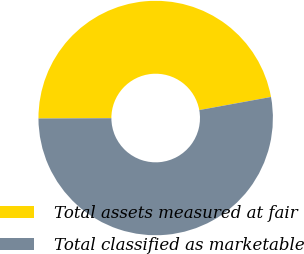Convert chart to OTSL. <chart><loc_0><loc_0><loc_500><loc_500><pie_chart><fcel>Total assets measured at fair<fcel>Total classified as marketable<nl><fcel>47.19%<fcel>52.81%<nl></chart> 